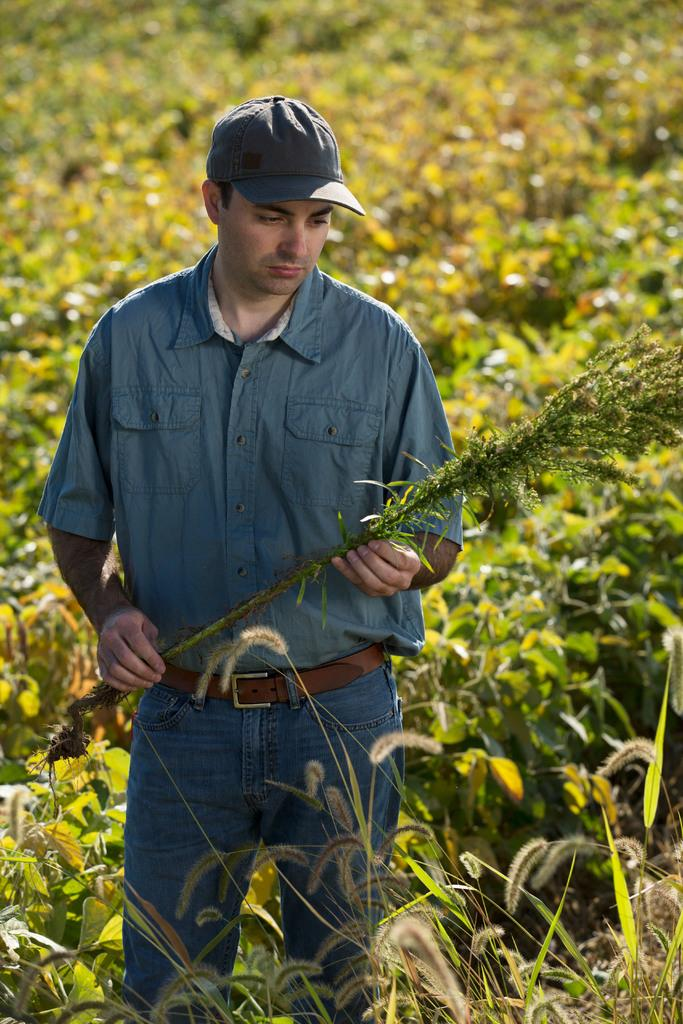What is the main subject of the image? The main subject of the image is a man. Can you describe the man's clothing? The man is wearing a shirt, a cap on his head, and a belt. What is the man holding in his hands? The man is holding a plant in his hands. What can be seen in the background of the image? There is a field with plants in the background of the image. What type of tree can be seen in the image? There is no tree present in the image; it features a man holding a plant and a field with plants in the background. How does the man's voice sound in the image, considering the acoustics? There is no information about the man's voice or the acoustics in the image, as it only shows a man holding a plant and a field with plants in the background. 